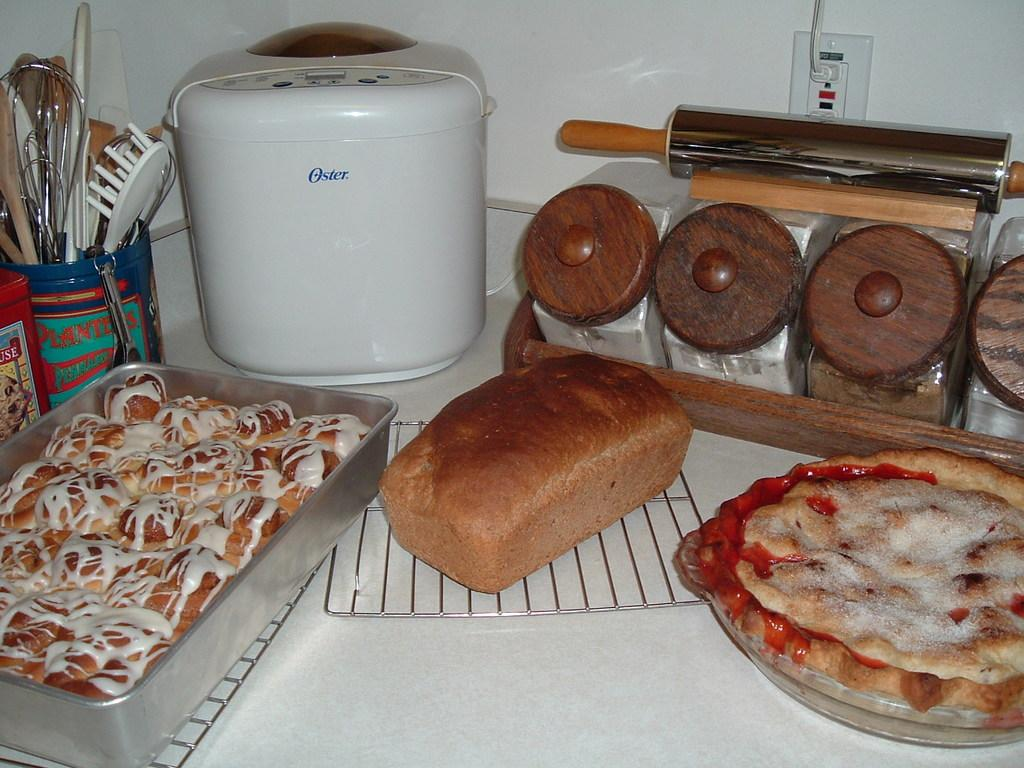Provide a one-sentence caption for the provided image. Three baked goods sit on a counter along with an Oster appliance. 